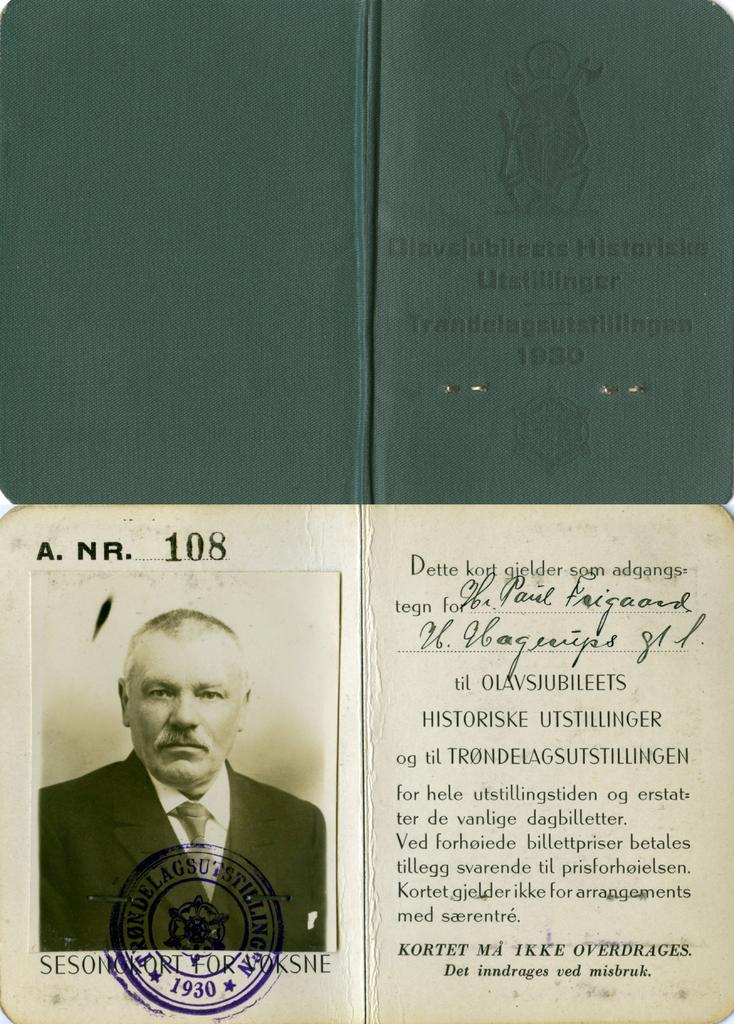What year was this password issued?
Provide a short and direct response. 1930. What number is on the passport?
Keep it short and to the point. 108. 